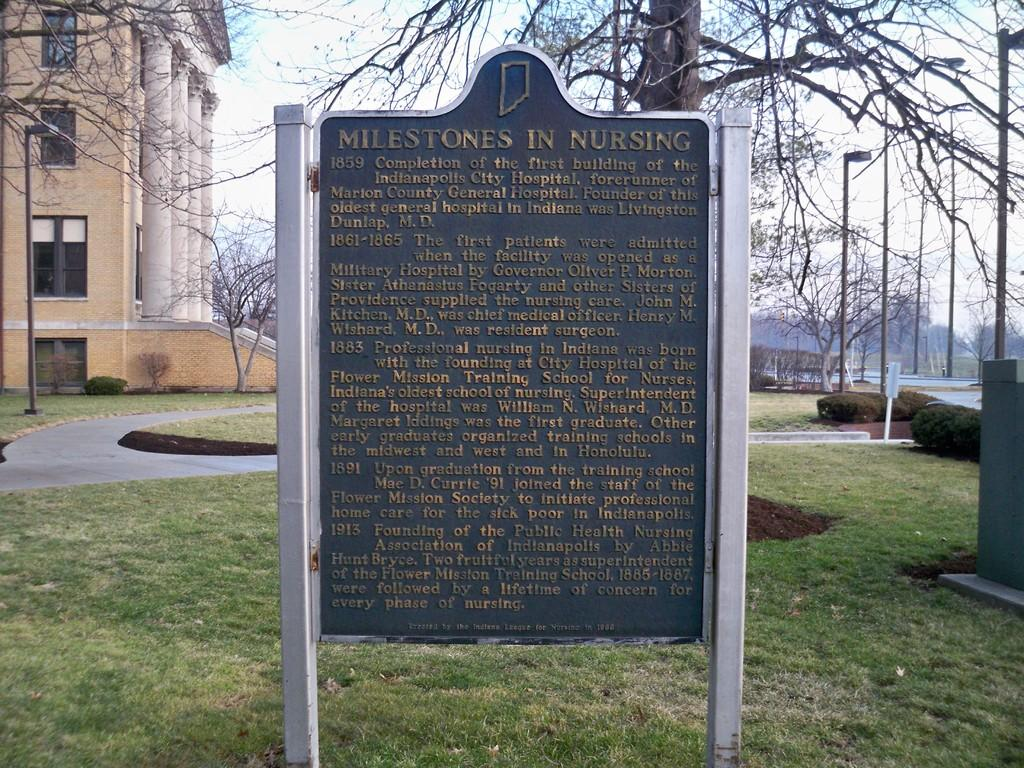What is the main object in the middle of the image? There is a board in the middle of the image. What type of natural environment can be seen in the background? There is grass, trees, and the sky visible in the background of the image. What type of structures are present in the background? Light poles and a building are present in the background of the image. Can you describe the time of day when the image was taken? The image was taken during the day. What type of pickle is being used to light the flame in the image? There is no pickle or flame present in the image. Can you tell me how many friends are visible in the image? There are no friends visible in the image. 